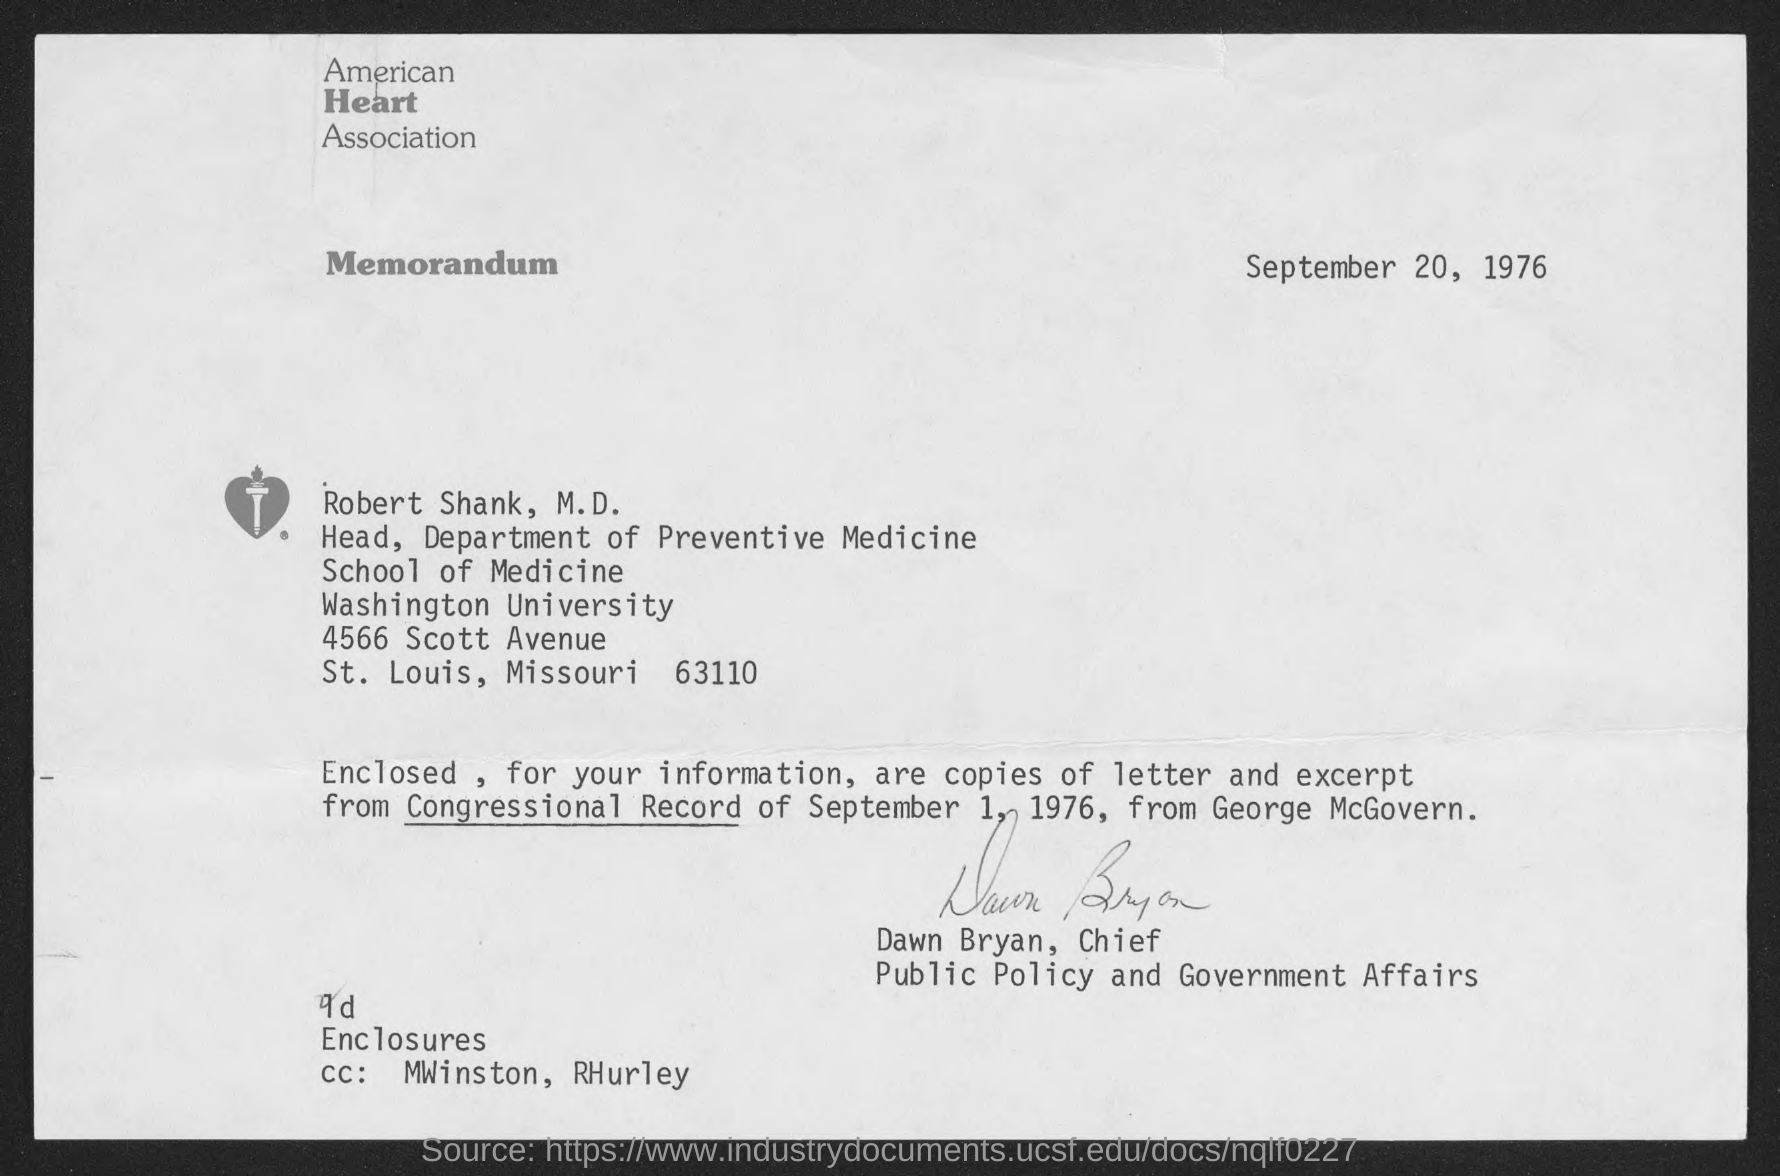Give some essential details in this illustration. The American Heart Association is mentioned on the letterhead. The memorandum states that the date mentioned is September 20, 1976. Robert E. Shank, M.D. is the Head of the Department of Preventive Medicine. The sender of this memorandum is Dawn Bryan. 